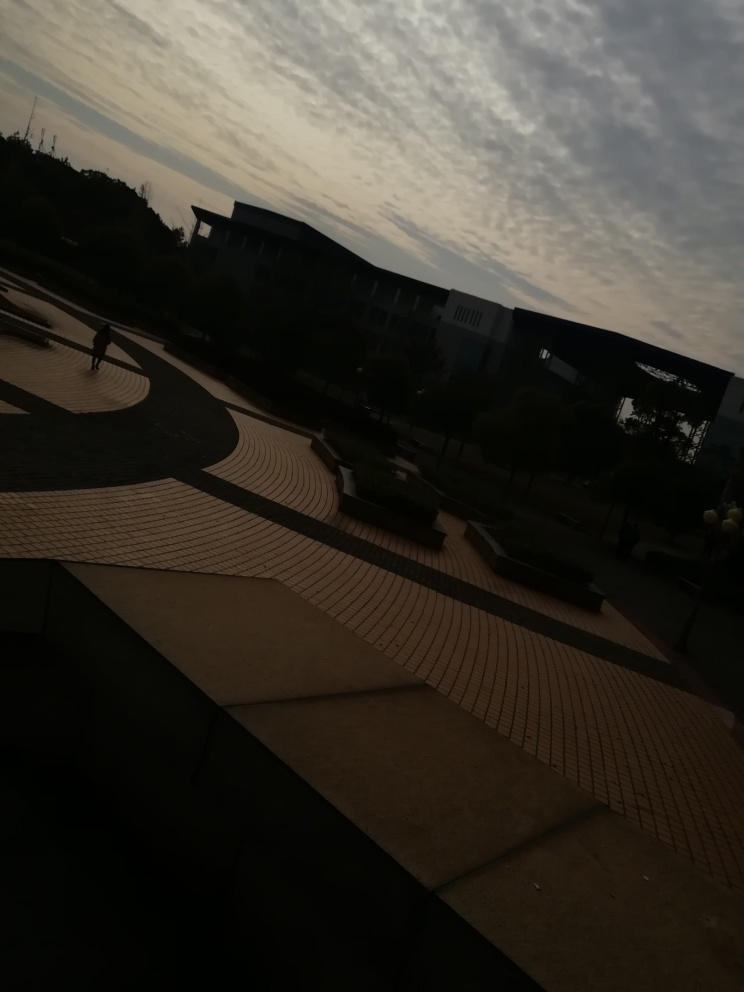Can you describe the architecture and the design of the space shown? The space shown in the image features modern architecture with a spacious plaza. It has curved steps and a patterned pavement that create a flowing design, leading the eye towards the building in the background, which has a minimalistic style with large panels and a silhouette that blends with the sky. 